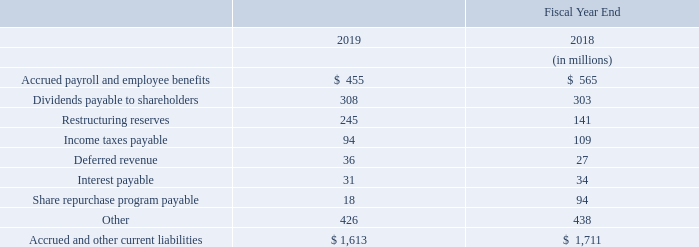10. Accrued and Other Current Liabilities
Accrued and other current liabilities consisted of the following:
What was the amount of Accrued and other current liabilities in 2019?
Answer scale should be: million. $ 1,613. In which years was Accrued and Other Current Liabilities calculated for? 2019, 2018. What are the components which comprise of Accrued and Other Current Liabilities? Accrued payroll and employee benefits, dividends payable to shareholders, restructuring reserves, income taxes payable, deferred revenue, interest payable, share repurchase program payable, other. In which year was the amount of Deferred revenue larger? 36>27
Answer: 2019. What was the change in deferred revenue in 2019 from 2018?
Answer scale should be: million. 36-27
Answer: 9. What was the percentage change in deferred revenue in 2019 from 2018?
Answer scale should be: percent. (36-27)/27
Answer: 33.33. 